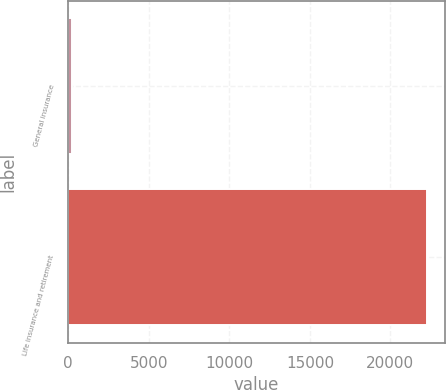<chart> <loc_0><loc_0><loc_500><loc_500><bar_chart><fcel>General insurance<fcel>Life insurance and retirement<nl><fcel>216<fcel>22257<nl></chart> 